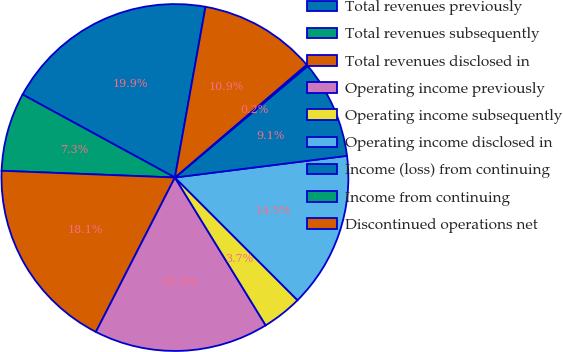<chart> <loc_0><loc_0><loc_500><loc_500><pie_chart><fcel>Total revenues previously<fcel>Total revenues subsequently<fcel>Total revenues disclosed in<fcel>Operating income previously<fcel>Operating income subsequently<fcel>Operating income disclosed in<fcel>Income (loss) from continuing<fcel>Income from continuing<fcel>Discontinued operations net<nl><fcel>19.88%<fcel>7.32%<fcel>18.09%<fcel>16.29%<fcel>3.73%<fcel>14.5%<fcel>9.12%<fcel>0.15%<fcel>10.91%<nl></chart> 